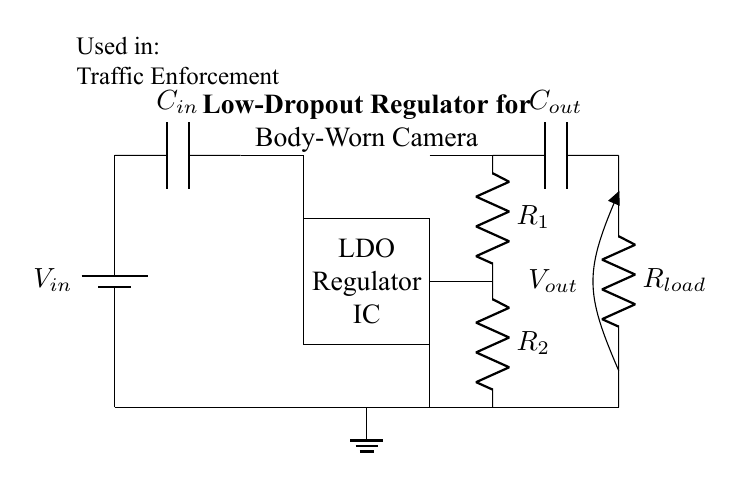What is the input voltage of this circuit? The input voltage is represented by the battery symbol labeled \(V_{in}\) at the top left of the diagram, indicating the source voltage supplied to the circuit.
Answer: \(V_{in}\) What type of regulator is shown in this circuit? The circuit contains an LDO regulator, denoted by the rectangle labeled "LDO Regulator IC” in the center of the diagram, which stands for Low-Dropout Regulator.
Answer: LDO Regulator How many resistors are present in the feedback network? There are two resistors in the feedback network, labeled \(R_1\) and \(R_2\), located vertically on the right side of the circuit.
Answer: 2 What is the purpose of the capacitor labeled \(C_{out}\)? The capacitor \(C_{out}\), connected in parallel with the load, is used to filter the output voltage from the regulator and stabilize the voltage supplied to the load.
Answer: Output filtering How does the output voltage relate to the input voltage? The output voltage \(V_{out}\) will have a small dropout compared to \(V_{in}\), which is typical for LDO regulators since they can maintain a stable output with a small difference from the input voltage.
Answer: Small dropout What is the load resistance in this regulator circuit? The load resistance is denoted by \(R_{load}\) in the diagram, which represents the device (in this case, a body-worn camera) that draws current from the output of the regulator.
Answer: \(R_{load}\) What is the function of the capacitor labeled \(C_{in}\)? The capacitor \(C_{in}\) at the input serves to stabilize the input voltage and reduce noise, ensuring that the regulator operates effectively without fluctuations.
Answer: Input stabilization 